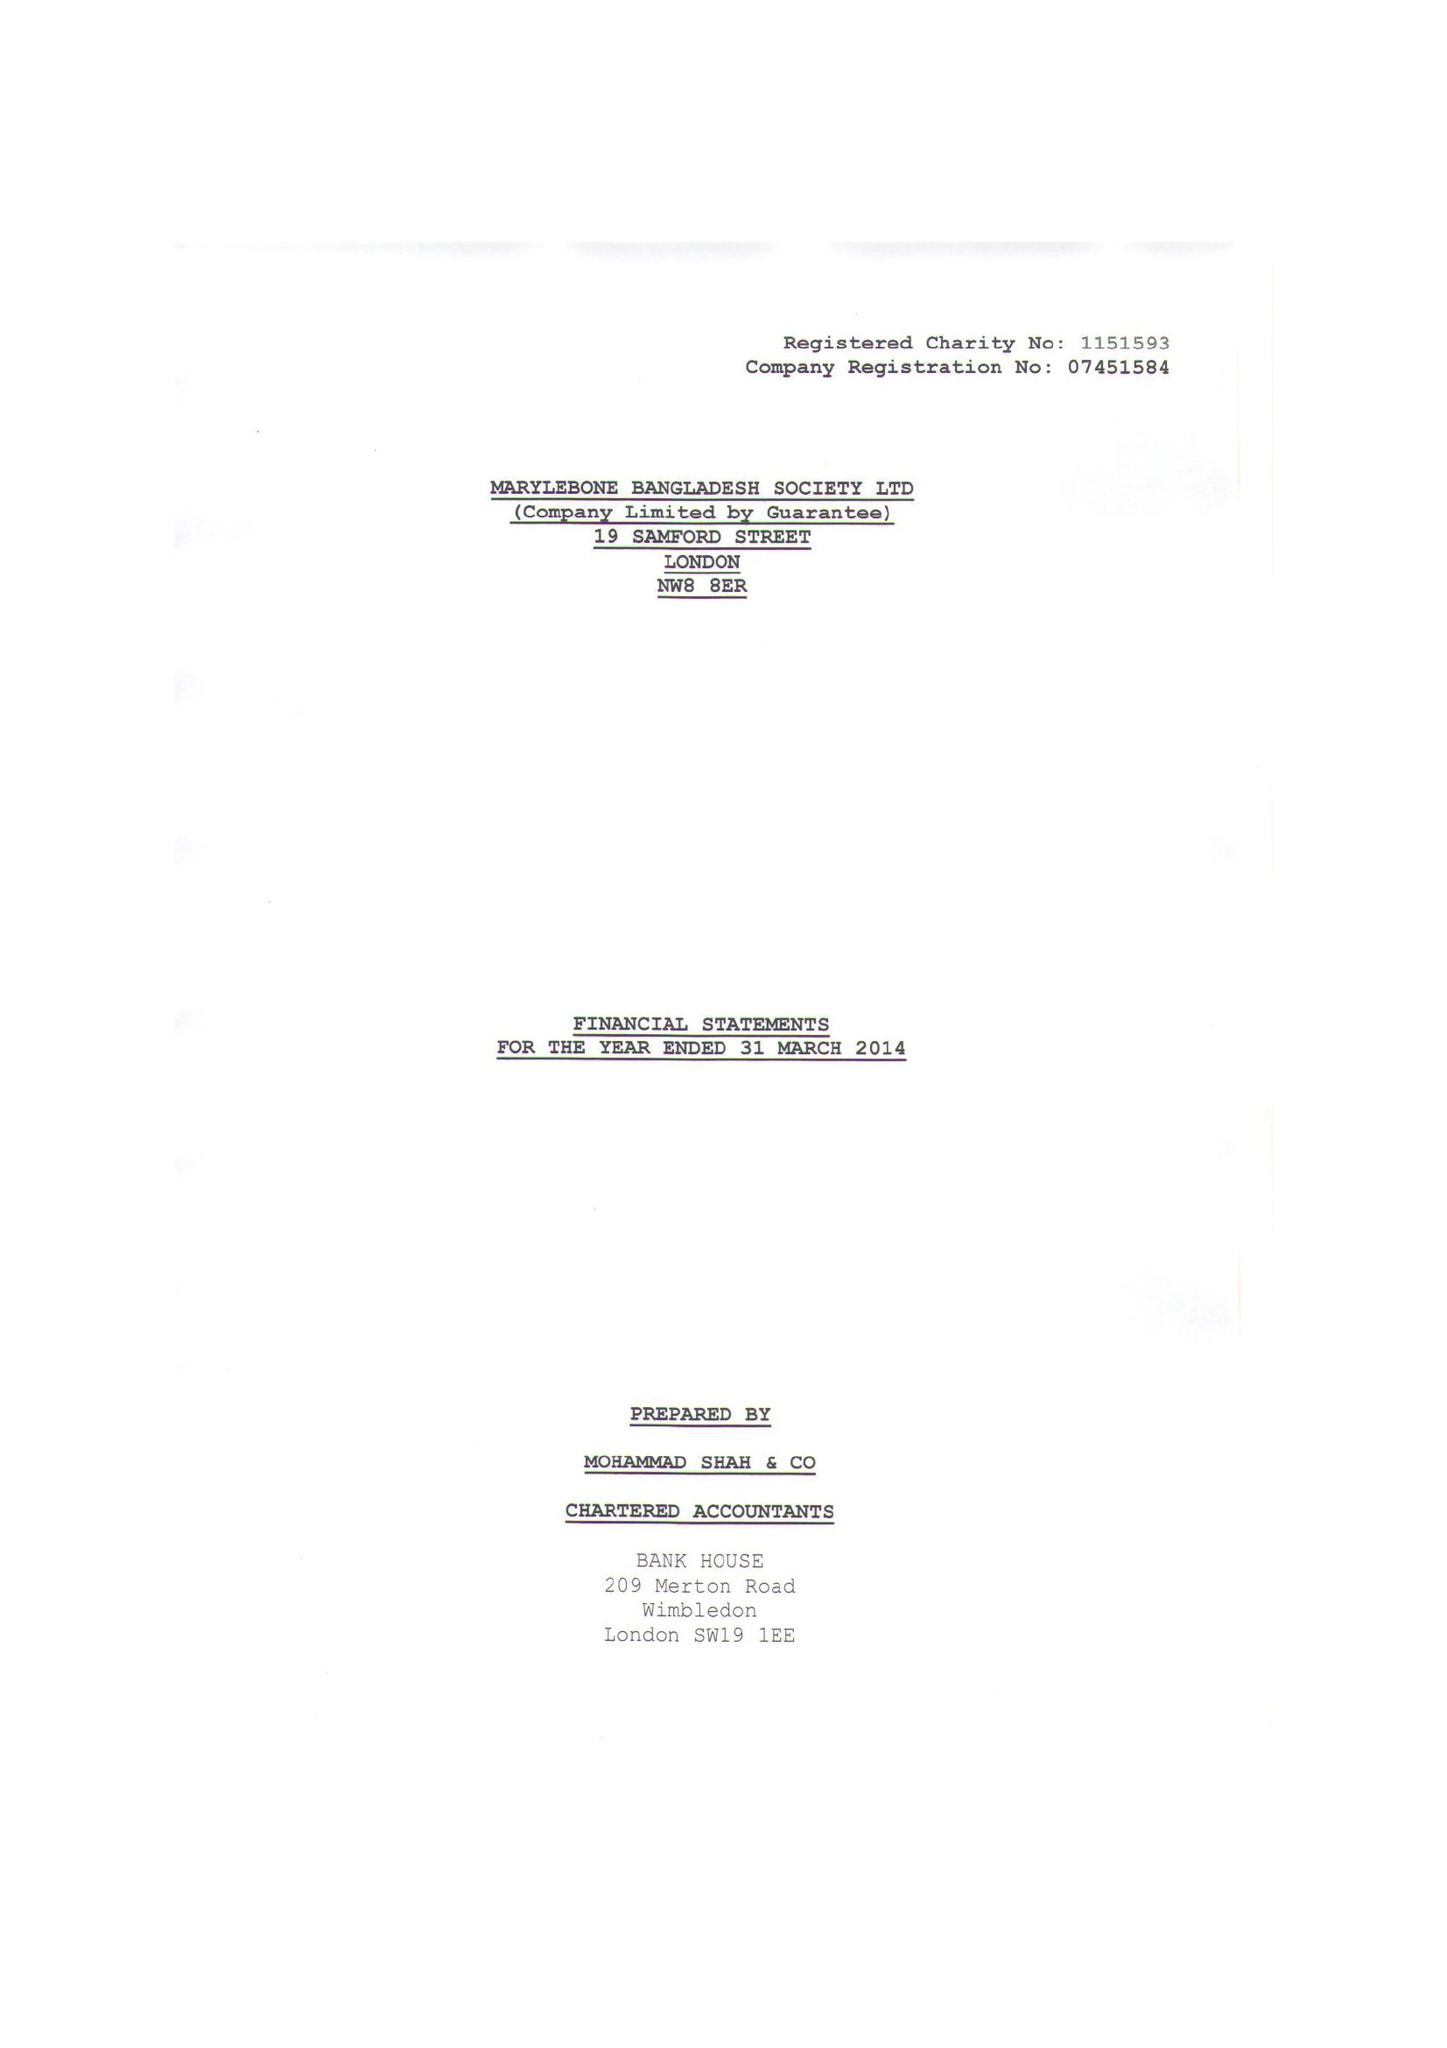What is the value for the charity_name?
Answer the question using a single word or phrase. Marylebone Bangladesh Society Ltd. 